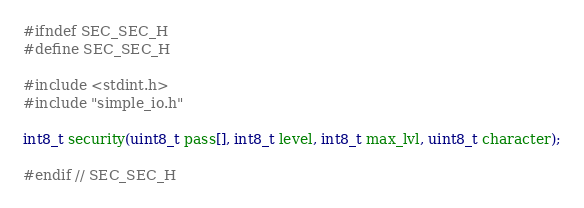Convert code to text. <code><loc_0><loc_0><loc_500><loc_500><_C_>#ifndef SEC_SEC_H
#define SEC_SEC_H

#include <stdint.h>
#include "simple_io.h"

int8_t security(uint8_t pass[], int8_t level, int8_t max_lvl, uint8_t character);

#endif // SEC_SEC_H
</code> 